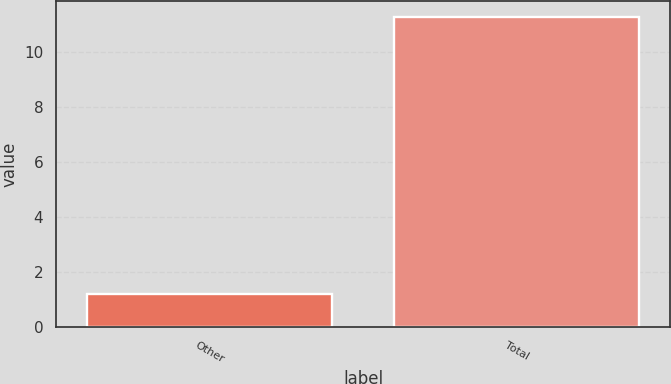Convert chart to OTSL. <chart><loc_0><loc_0><loc_500><loc_500><bar_chart><fcel>Other<fcel>Total<nl><fcel>1.2<fcel>11.3<nl></chart> 